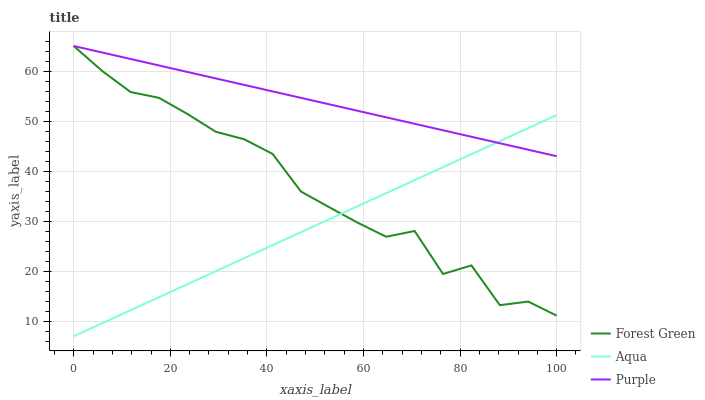Does Aqua have the minimum area under the curve?
Answer yes or no. Yes. Does Purple have the maximum area under the curve?
Answer yes or no. Yes. Does Forest Green have the minimum area under the curve?
Answer yes or no. No. Does Forest Green have the maximum area under the curve?
Answer yes or no. No. Is Aqua the smoothest?
Answer yes or no. Yes. Is Forest Green the roughest?
Answer yes or no. Yes. Is Forest Green the smoothest?
Answer yes or no. No. Is Aqua the roughest?
Answer yes or no. No. Does Aqua have the lowest value?
Answer yes or no. Yes. Does Forest Green have the lowest value?
Answer yes or no. No. Does Forest Green have the highest value?
Answer yes or no. Yes. Does Aqua have the highest value?
Answer yes or no. No. Does Forest Green intersect Purple?
Answer yes or no. Yes. Is Forest Green less than Purple?
Answer yes or no. No. Is Forest Green greater than Purple?
Answer yes or no. No. 